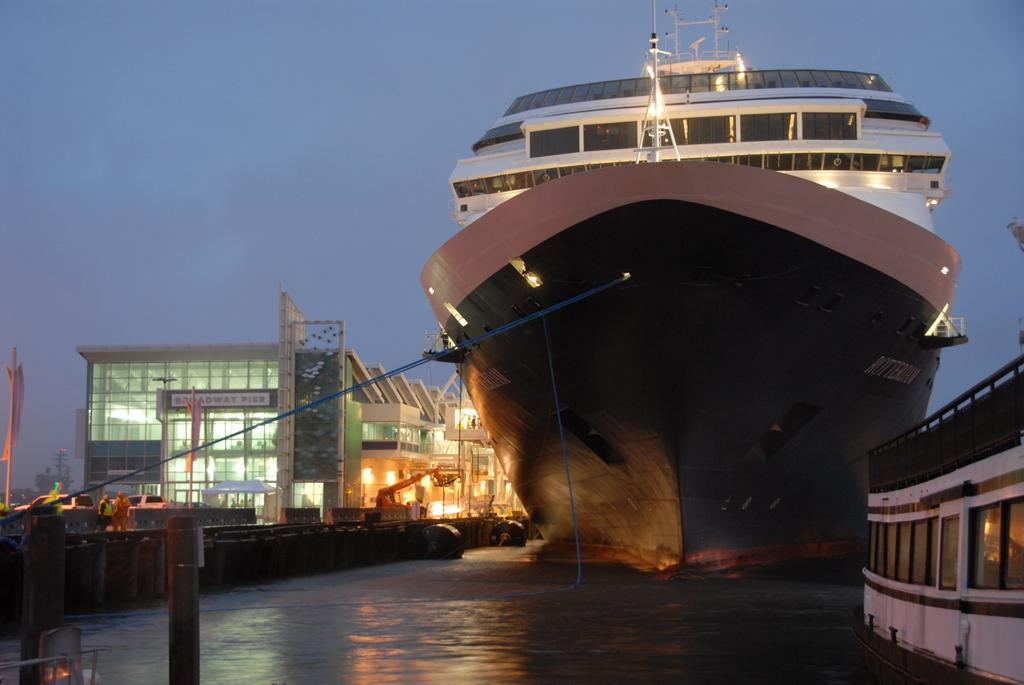<image>
Describe the image concisely. A huge ship docking at the Broadway Pier. 